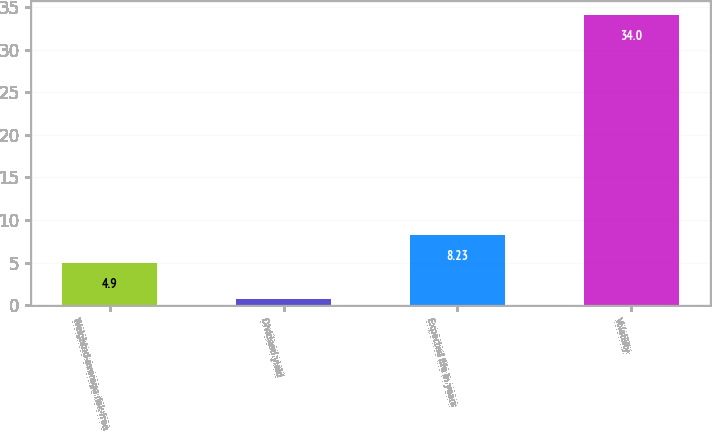<chart> <loc_0><loc_0><loc_500><loc_500><bar_chart><fcel>Weighted-average risk-free<fcel>Dividend yield<fcel>Expected life in years<fcel>Volatility<nl><fcel>4.9<fcel>0.7<fcel>8.23<fcel>34<nl></chart> 